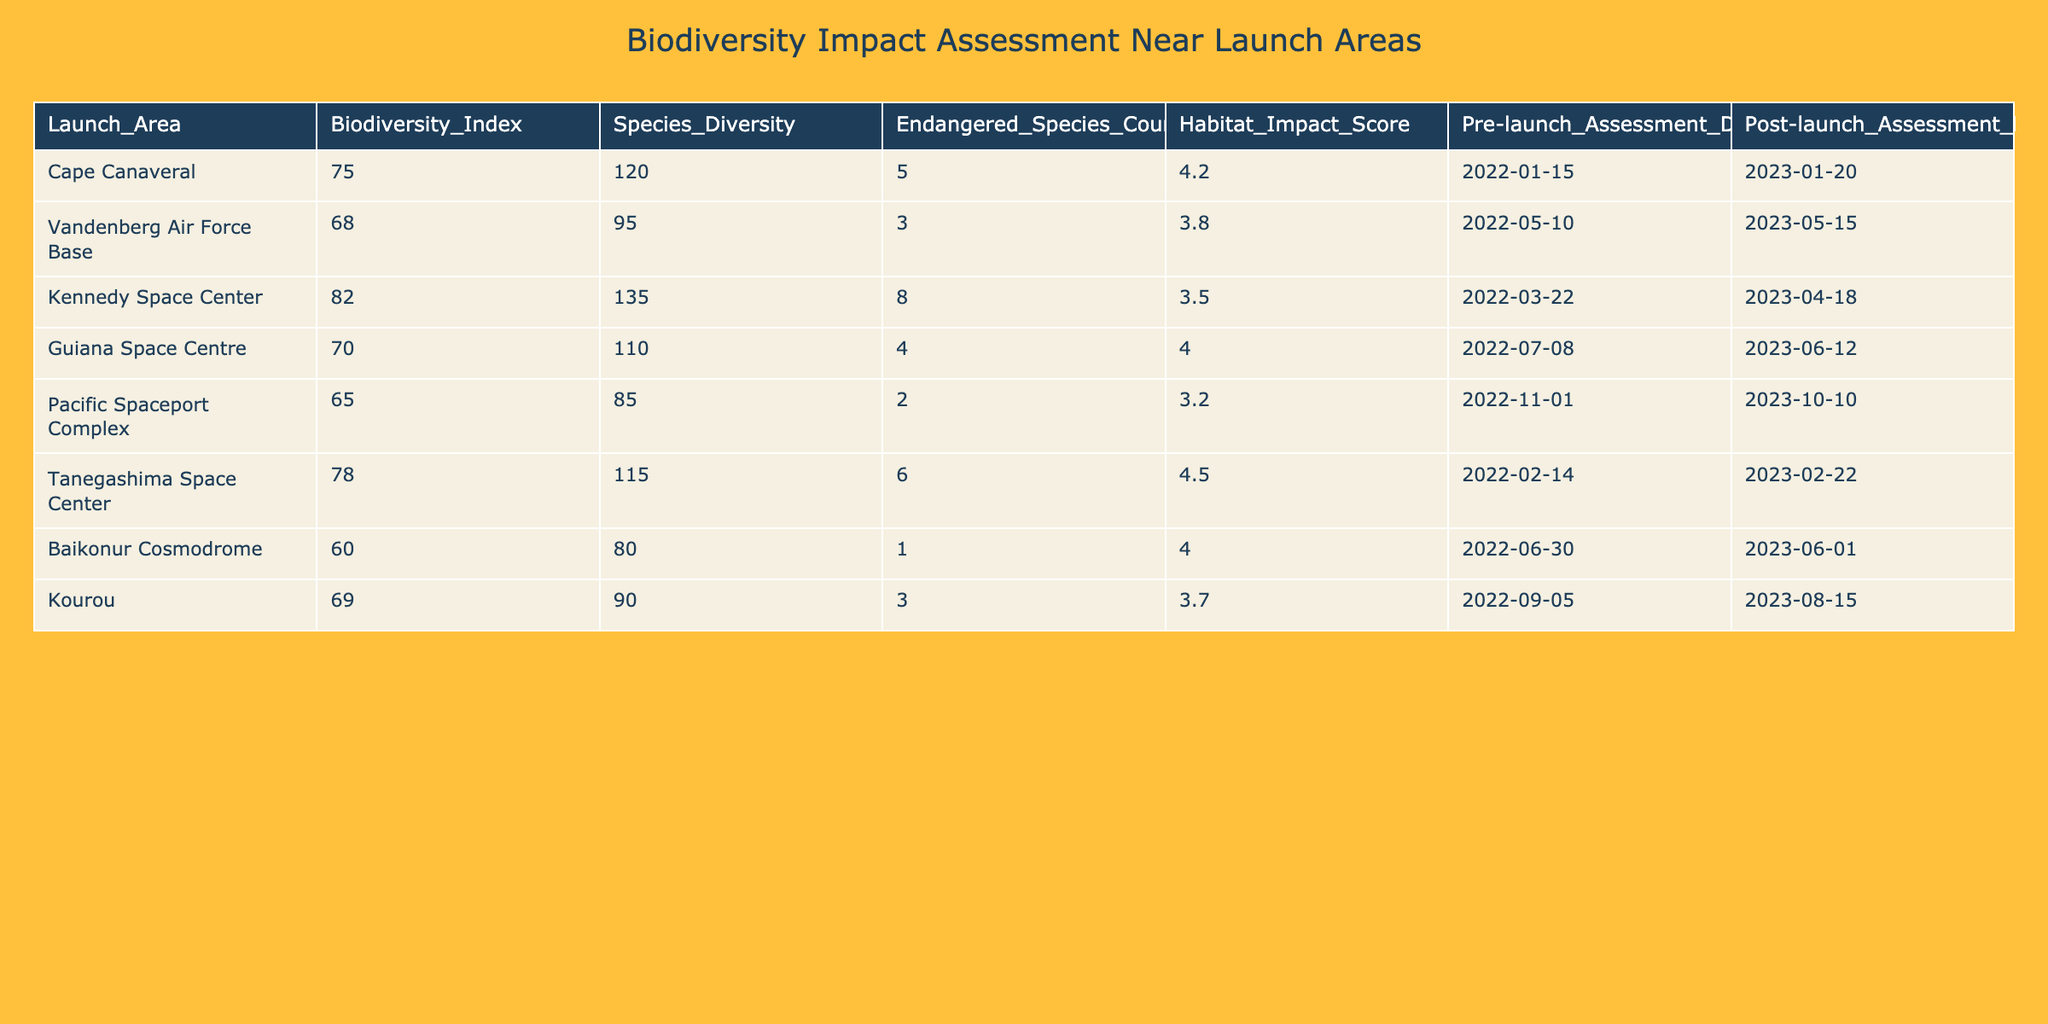What is the highest Biodiversity Index among the launch areas? The Biodiversity Index is a numerical value listed under the Biodiversity_Index column. By reviewing the values, Cape Canaveral has the highest Biodiversity Index at 75.
Answer: 75 How many endangered species were counted at the Kennedy Space Center? The Endangered Species Count is directly provided in the table for each launch area. For Kennedy Space Center, the count is 8.
Answer: 8 Which launch area had the lowest Habitat Impact Score? The Habitat Impact Score is listed in the corresponding column for each area. By comparing the scores, Pacific Spaceport Complex has the lowest score of 3.2.
Answer: 3.2 What is the total count of endangered species across all launch areas? The total endangered species count can be obtained by summing each value in the Endangered Species Count column: 5 + 3 + 8 + 4 + 2 + 6 + 1 + 3 = 32.
Answer: 32 Is there any launch area that has an Endangered Species Count greater than 6? By examining the Endangered Species Count column, Kennedy Space Center has a count of 8, which is greater than 6.
Answer: Yes Which launch area had a decline in the Biodiversity Index after launches? To check for a decline, it is necessary to compare the pre-launch and post-launch assessments. However, all Biodiversity Indices remain constant in the table as only the Biodiversity Index is presented without separate pre-launch or post-launch data—a decline cannot be determined from the current data structure.
Answer: No decline can be determined What is the average Habitat Impact Score of all the launch areas? First, sum all the Habitat Impact Scores: 4.2 + 3.8 + 3.5 + 4.0 + 3.2 + 4.5 + 4.0 + 3.7 = 31.9. There are 8 launch areas, so the average is 31.9 / 8 = 3.9875, which rounds to approximately 3.99.
Answer: 3.99 Which areas have a Biodiversity Index above 70? By reviewing the Biodiversity Index column, Cape Canaveral (75), Kennedy Space Center (82), and Tanegashima Space Center (78) are above 70.
Answer: Cape Canaveral, Kennedy Space Center, Tanegashima Space Center How does the Species Diversity at Baikonur Cosmodrome compare with the average of all launch areas? The Species Diversity at Baikonur is 80. To find the average, sum all values (120 + 95 + 135 + 110 + 85 + 115 + 80 + 90 = 830) and divide by 8, resulting in an average of 103.75. Baikonur is below the average.
Answer: Below average 